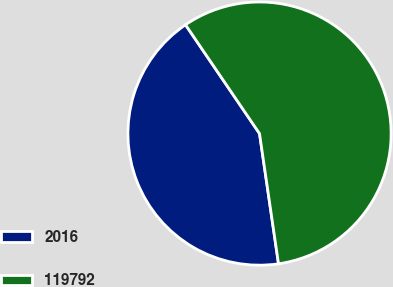Convert chart to OTSL. <chart><loc_0><loc_0><loc_500><loc_500><pie_chart><fcel>2016<fcel>119792<nl><fcel>42.8%<fcel>57.2%<nl></chart> 